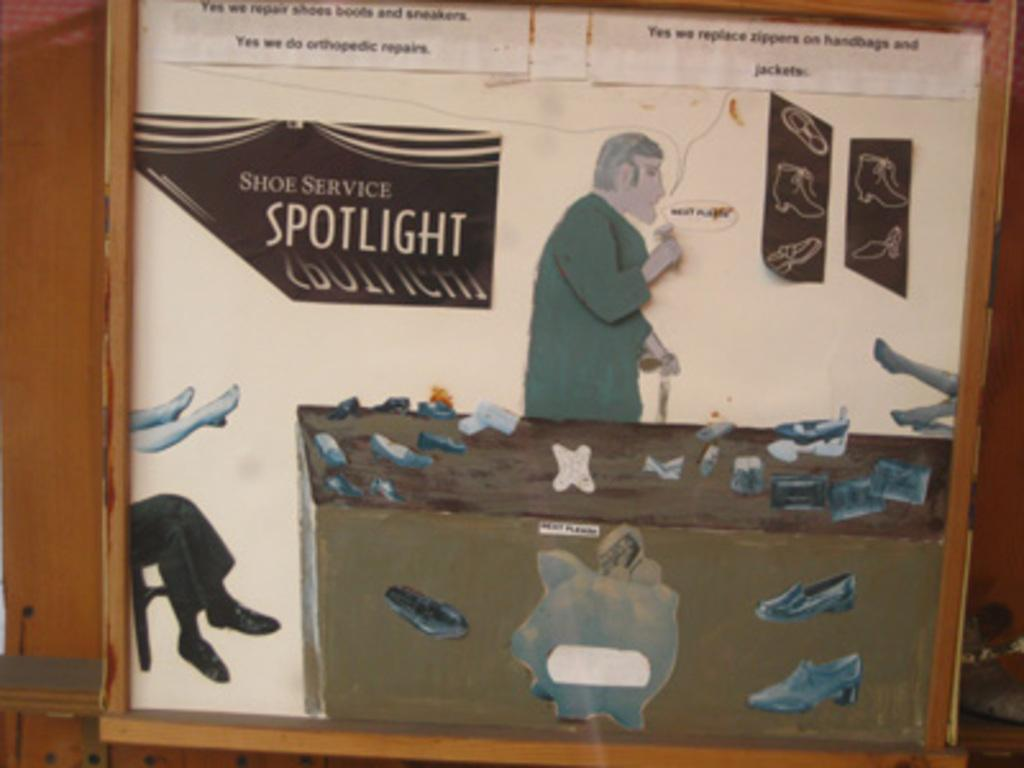What is the main object in the image? There is a board in the image. What types of images are present on the board? The board contains images of persons, a table, shoes, a person's legs, and a chair. Is there any text visible on the board? Yes, there is text visible on the board. How steep is the slope in the image? There is no slope present in the image; it features a board with various images and text. What type of peace is depicted in the image? There is no depiction of peace in the image; it contains images of persons, a table, shoes, a person's legs, and a chair, along with text. 